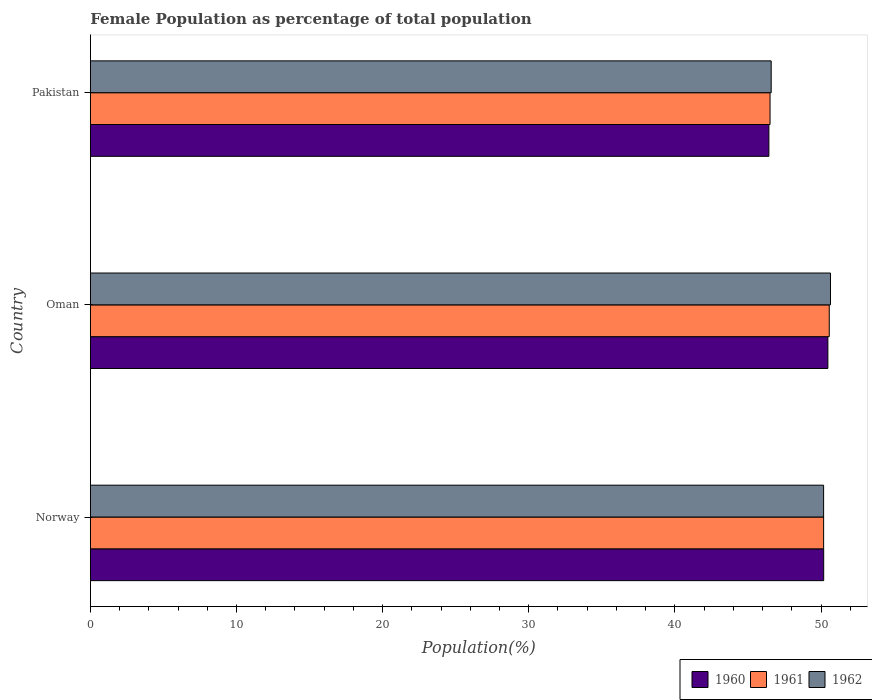How many groups of bars are there?
Your answer should be compact. 3. Are the number of bars on each tick of the Y-axis equal?
Keep it short and to the point. Yes. How many bars are there on the 3rd tick from the top?
Provide a short and direct response. 3. What is the label of the 1st group of bars from the top?
Your answer should be compact. Pakistan. What is the female population in in 1962 in Pakistan?
Offer a very short reply. 46.59. Across all countries, what is the maximum female population in in 1962?
Offer a very short reply. 50.65. Across all countries, what is the minimum female population in in 1961?
Offer a very short reply. 46.51. In which country was the female population in in 1962 maximum?
Provide a succinct answer. Oman. In which country was the female population in in 1961 minimum?
Provide a short and direct response. Pakistan. What is the total female population in in 1961 in the graph?
Ensure brevity in your answer.  147.26. What is the difference between the female population in in 1962 in Norway and that in Oman?
Provide a succinct answer. -0.47. What is the difference between the female population in in 1960 in Pakistan and the female population in in 1961 in Oman?
Your answer should be compact. -4.13. What is the average female population in in 1962 per country?
Provide a short and direct response. 49.14. What is the difference between the female population in in 1962 and female population in in 1961 in Pakistan?
Keep it short and to the point. 0.08. In how many countries, is the female population in in 1961 greater than 38 %?
Make the answer very short. 3. What is the ratio of the female population in in 1960 in Norway to that in Oman?
Offer a terse response. 0.99. Is the female population in in 1962 in Oman less than that in Pakistan?
Your response must be concise. No. What is the difference between the highest and the second highest female population in in 1962?
Make the answer very short. 0.47. What is the difference between the highest and the lowest female population in in 1960?
Provide a short and direct response. 4.04. Is the sum of the female population in in 1962 in Norway and Oman greater than the maximum female population in in 1961 across all countries?
Ensure brevity in your answer.  Yes. What does the 1st bar from the top in Oman represents?
Keep it short and to the point. 1962. Is it the case that in every country, the sum of the female population in in 1960 and female population in in 1962 is greater than the female population in in 1961?
Make the answer very short. Yes. How many countries are there in the graph?
Offer a very short reply. 3. What is the difference between two consecutive major ticks on the X-axis?
Your answer should be compact. 10. Does the graph contain any zero values?
Make the answer very short. No. Does the graph contain grids?
Offer a very short reply. No. How many legend labels are there?
Keep it short and to the point. 3. How are the legend labels stacked?
Give a very brief answer. Horizontal. What is the title of the graph?
Offer a very short reply. Female Population as percentage of total population. What is the label or title of the X-axis?
Make the answer very short. Population(%). What is the label or title of the Y-axis?
Ensure brevity in your answer.  Country. What is the Population(%) in 1960 in Norway?
Your answer should be compact. 50.18. What is the Population(%) in 1961 in Norway?
Your answer should be very brief. 50.18. What is the Population(%) of 1962 in Norway?
Offer a very short reply. 50.18. What is the Population(%) of 1960 in Oman?
Provide a succinct answer. 50.47. What is the Population(%) in 1961 in Oman?
Provide a short and direct response. 50.56. What is the Population(%) in 1962 in Oman?
Offer a terse response. 50.65. What is the Population(%) of 1960 in Pakistan?
Give a very brief answer. 46.43. What is the Population(%) of 1961 in Pakistan?
Keep it short and to the point. 46.51. What is the Population(%) in 1962 in Pakistan?
Your answer should be very brief. 46.59. Across all countries, what is the maximum Population(%) in 1960?
Keep it short and to the point. 50.47. Across all countries, what is the maximum Population(%) in 1961?
Keep it short and to the point. 50.56. Across all countries, what is the maximum Population(%) of 1962?
Your answer should be compact. 50.65. Across all countries, what is the minimum Population(%) of 1960?
Your answer should be very brief. 46.43. Across all countries, what is the minimum Population(%) in 1961?
Your answer should be compact. 46.51. Across all countries, what is the minimum Population(%) in 1962?
Provide a succinct answer. 46.59. What is the total Population(%) of 1960 in the graph?
Offer a terse response. 147.09. What is the total Population(%) of 1961 in the graph?
Ensure brevity in your answer.  147.26. What is the total Population(%) of 1962 in the graph?
Your response must be concise. 147.42. What is the difference between the Population(%) in 1960 in Norway and that in Oman?
Keep it short and to the point. -0.29. What is the difference between the Population(%) in 1961 in Norway and that in Oman?
Your response must be concise. -0.38. What is the difference between the Population(%) in 1962 in Norway and that in Oman?
Offer a very short reply. -0.47. What is the difference between the Population(%) of 1960 in Norway and that in Pakistan?
Keep it short and to the point. 3.75. What is the difference between the Population(%) in 1961 in Norway and that in Pakistan?
Give a very brief answer. 3.67. What is the difference between the Population(%) of 1962 in Norway and that in Pakistan?
Provide a succinct answer. 3.59. What is the difference between the Population(%) in 1960 in Oman and that in Pakistan?
Your response must be concise. 4.04. What is the difference between the Population(%) in 1961 in Oman and that in Pakistan?
Your answer should be compact. 4.05. What is the difference between the Population(%) of 1962 in Oman and that in Pakistan?
Your answer should be very brief. 4.06. What is the difference between the Population(%) of 1960 in Norway and the Population(%) of 1961 in Oman?
Provide a short and direct response. -0.38. What is the difference between the Population(%) of 1960 in Norway and the Population(%) of 1962 in Oman?
Your response must be concise. -0.47. What is the difference between the Population(%) in 1961 in Norway and the Population(%) in 1962 in Oman?
Ensure brevity in your answer.  -0.47. What is the difference between the Population(%) of 1960 in Norway and the Population(%) of 1961 in Pakistan?
Give a very brief answer. 3.67. What is the difference between the Population(%) in 1960 in Norway and the Population(%) in 1962 in Pakistan?
Your answer should be very brief. 3.59. What is the difference between the Population(%) of 1961 in Norway and the Population(%) of 1962 in Pakistan?
Provide a short and direct response. 3.59. What is the difference between the Population(%) in 1960 in Oman and the Population(%) in 1961 in Pakistan?
Offer a terse response. 3.96. What is the difference between the Population(%) of 1960 in Oman and the Population(%) of 1962 in Pakistan?
Ensure brevity in your answer.  3.88. What is the difference between the Population(%) of 1961 in Oman and the Population(%) of 1962 in Pakistan?
Keep it short and to the point. 3.97. What is the average Population(%) of 1960 per country?
Make the answer very short. 49.03. What is the average Population(%) of 1961 per country?
Make the answer very short. 49.09. What is the average Population(%) in 1962 per country?
Ensure brevity in your answer.  49.14. What is the difference between the Population(%) in 1960 and Population(%) in 1961 in Norway?
Your answer should be very brief. 0. What is the difference between the Population(%) of 1960 and Population(%) of 1962 in Norway?
Ensure brevity in your answer.  0.01. What is the difference between the Population(%) in 1961 and Population(%) in 1962 in Norway?
Offer a terse response. 0. What is the difference between the Population(%) of 1960 and Population(%) of 1961 in Oman?
Give a very brief answer. -0.09. What is the difference between the Population(%) in 1960 and Population(%) in 1962 in Oman?
Make the answer very short. -0.18. What is the difference between the Population(%) of 1961 and Population(%) of 1962 in Oman?
Provide a succinct answer. -0.08. What is the difference between the Population(%) of 1960 and Population(%) of 1961 in Pakistan?
Provide a short and direct response. -0.08. What is the difference between the Population(%) in 1960 and Population(%) in 1962 in Pakistan?
Keep it short and to the point. -0.16. What is the difference between the Population(%) of 1961 and Population(%) of 1962 in Pakistan?
Your answer should be very brief. -0.08. What is the ratio of the Population(%) of 1961 in Norway to that in Oman?
Make the answer very short. 0.99. What is the ratio of the Population(%) of 1960 in Norway to that in Pakistan?
Offer a very short reply. 1.08. What is the ratio of the Population(%) in 1961 in Norway to that in Pakistan?
Your response must be concise. 1.08. What is the ratio of the Population(%) of 1962 in Norway to that in Pakistan?
Your answer should be compact. 1.08. What is the ratio of the Population(%) in 1960 in Oman to that in Pakistan?
Offer a terse response. 1.09. What is the ratio of the Population(%) of 1961 in Oman to that in Pakistan?
Provide a succinct answer. 1.09. What is the ratio of the Population(%) of 1962 in Oman to that in Pakistan?
Offer a very short reply. 1.09. What is the difference between the highest and the second highest Population(%) of 1960?
Make the answer very short. 0.29. What is the difference between the highest and the second highest Population(%) of 1961?
Your answer should be compact. 0.38. What is the difference between the highest and the second highest Population(%) in 1962?
Your answer should be compact. 0.47. What is the difference between the highest and the lowest Population(%) of 1960?
Your response must be concise. 4.04. What is the difference between the highest and the lowest Population(%) of 1961?
Provide a short and direct response. 4.05. What is the difference between the highest and the lowest Population(%) of 1962?
Keep it short and to the point. 4.06. 